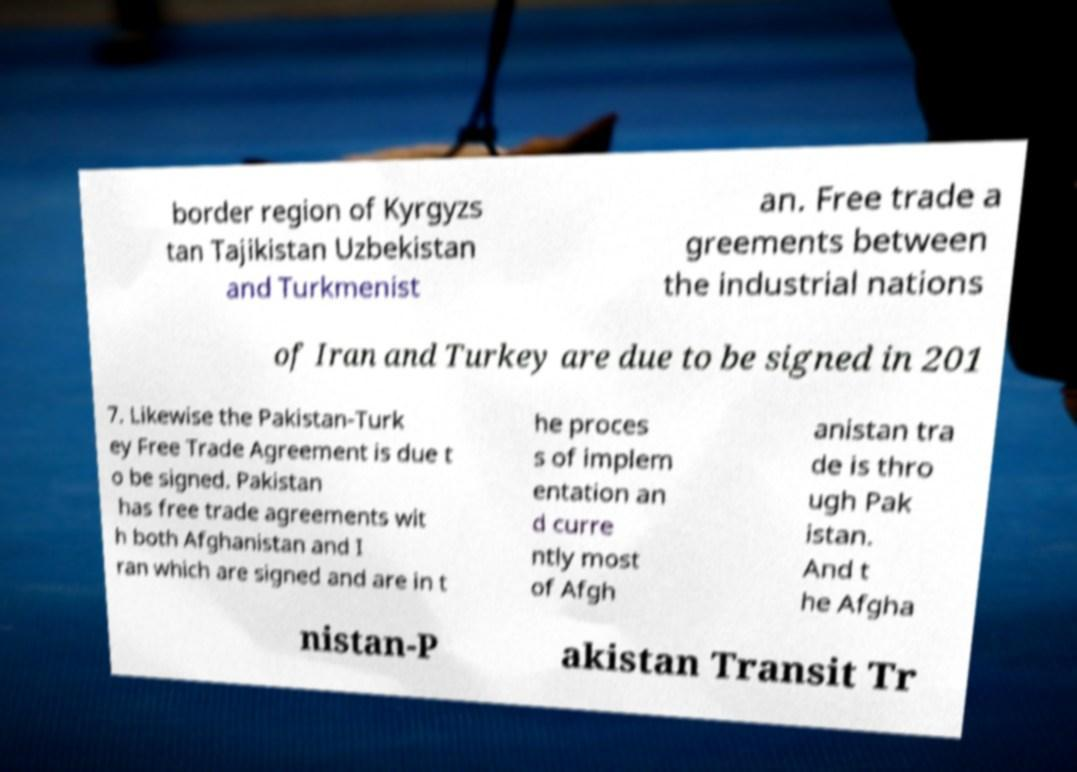Could you assist in decoding the text presented in this image and type it out clearly? border region of Kyrgyzs tan Tajikistan Uzbekistan and Turkmenist an. Free trade a greements between the industrial nations of Iran and Turkey are due to be signed in 201 7. Likewise the Pakistan-Turk ey Free Trade Agreement is due t o be signed. Pakistan has free trade agreements wit h both Afghanistan and I ran which are signed and are in t he proces s of implem entation an d curre ntly most of Afgh anistan tra de is thro ugh Pak istan. And t he Afgha nistan-P akistan Transit Tr 